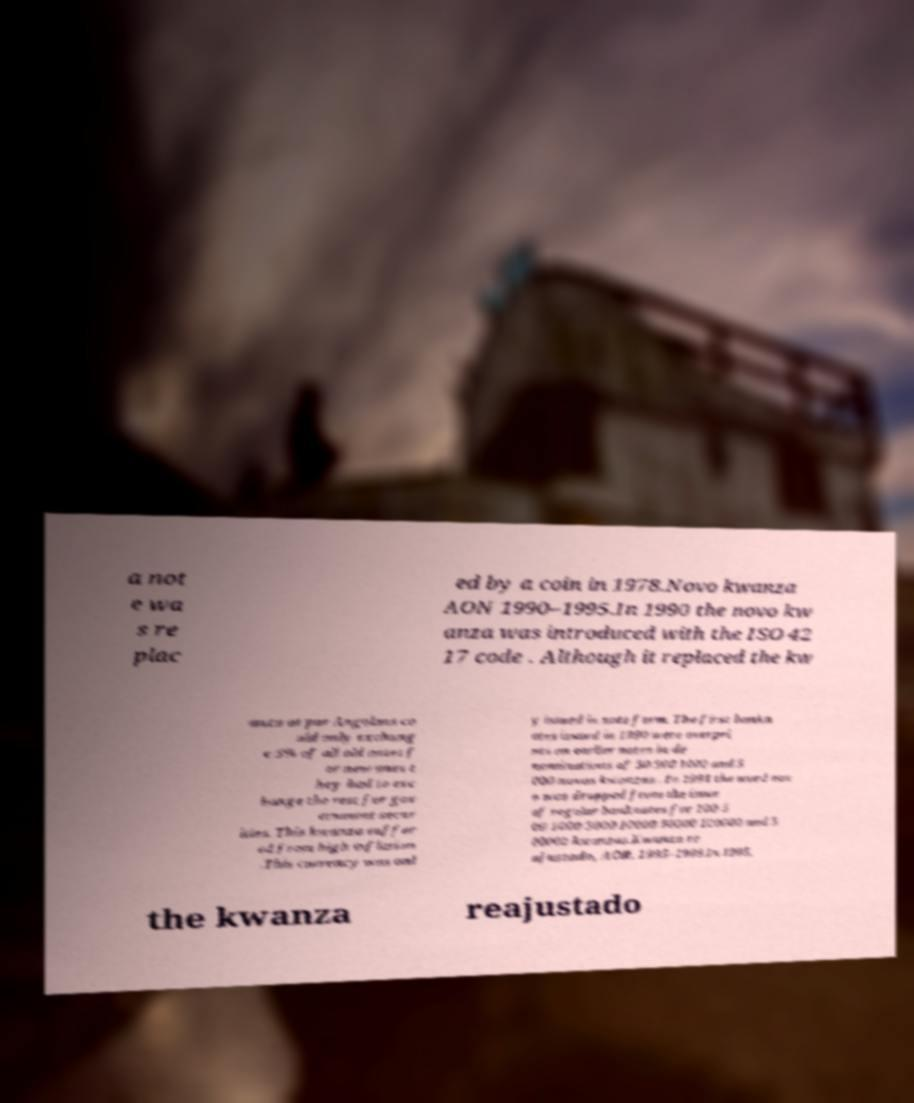For documentation purposes, I need the text within this image transcribed. Could you provide that? a not e wa s re plac ed by a coin in 1978.Novo kwanza AON 1990–1995.In 1990 the novo kw anza was introduced with the ISO 42 17 code . Although it replaced the kw anza at par Angolans co uld only exchang e 5% of all old notes f or new ones t hey had to exc hange the rest for gov ernment secur ities. This kwanza suffer ed from high inflation .This currency was onl y issued in note form. The first bankn otes issued in 1990 were overpri nts on earlier notes in de nominations of 50 500 1000 and 5 000 novos kwanzas . In 1991 the word nov o was dropped from the issue of regular banknotes for 100 5 00 1000 5000 10000 50000 100000 and 5 00000 kwanzas.Kwanza re ajustado, AOR, 1995–1999.In 1995, the kwanza reajustado 